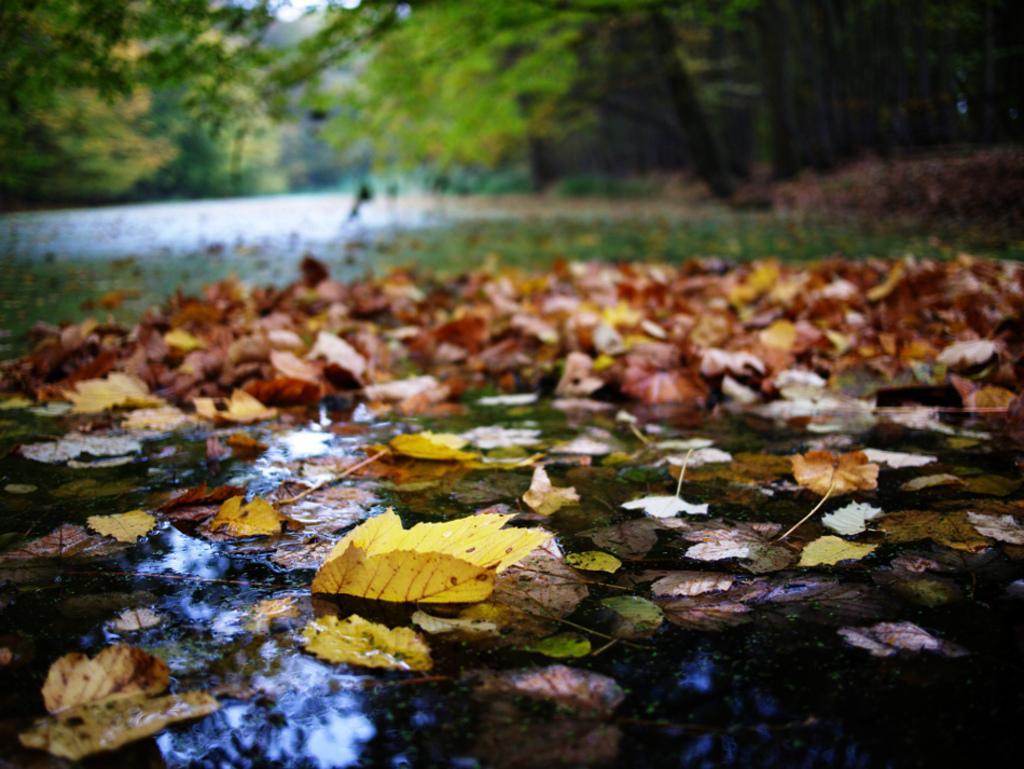How would you summarize this image in a sentence or two? In this image I can see few leaves. They are in yellow,brown and green color. I can see water. Back I can see trees. 